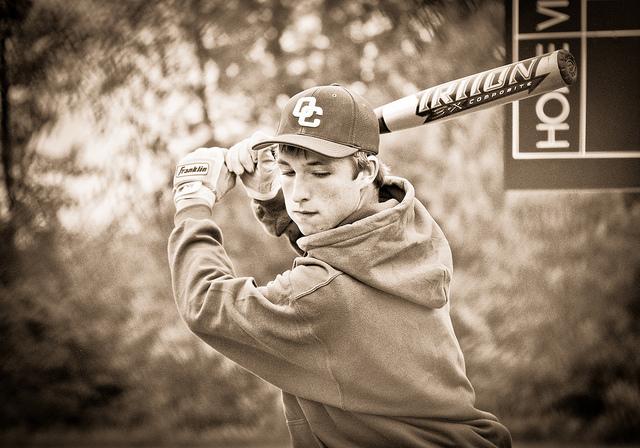What is he holding?
Write a very short answer. Baseball bat. What does the boy's hat say?
Answer briefly. Oc. What does it say on the bat?
Quick response, please. Triton. What color is the photo?
Give a very brief answer. Black and white. 